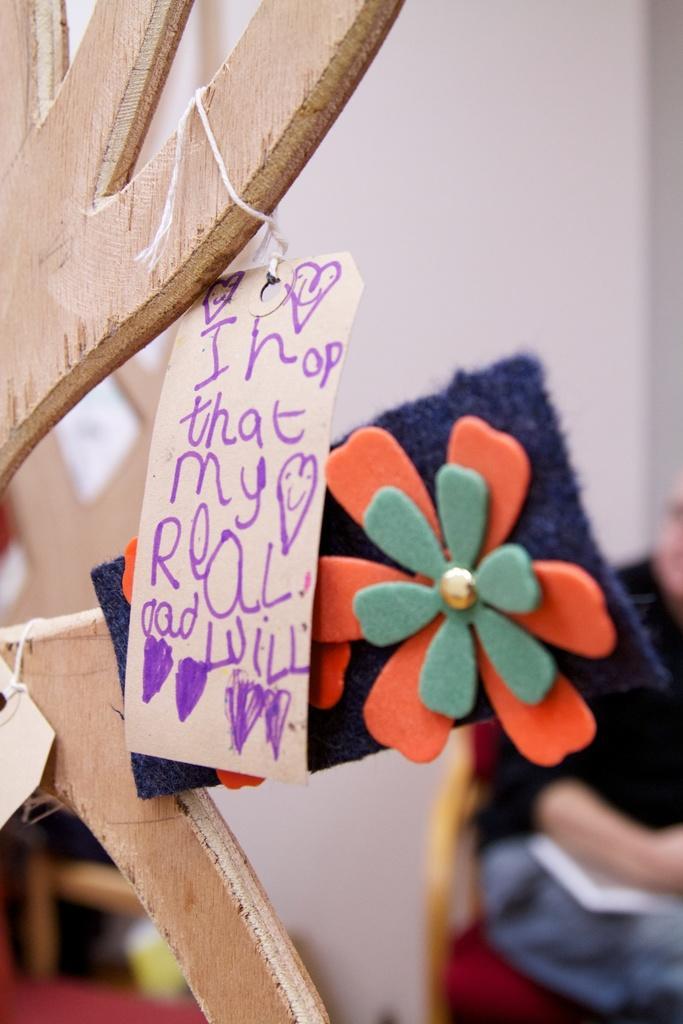How would you summarize this image in a sentence or two? In this image we can see there is a stick with a board and a cloth with flower design. And at the back there is a person sitting on the chair. And there is a wall. 